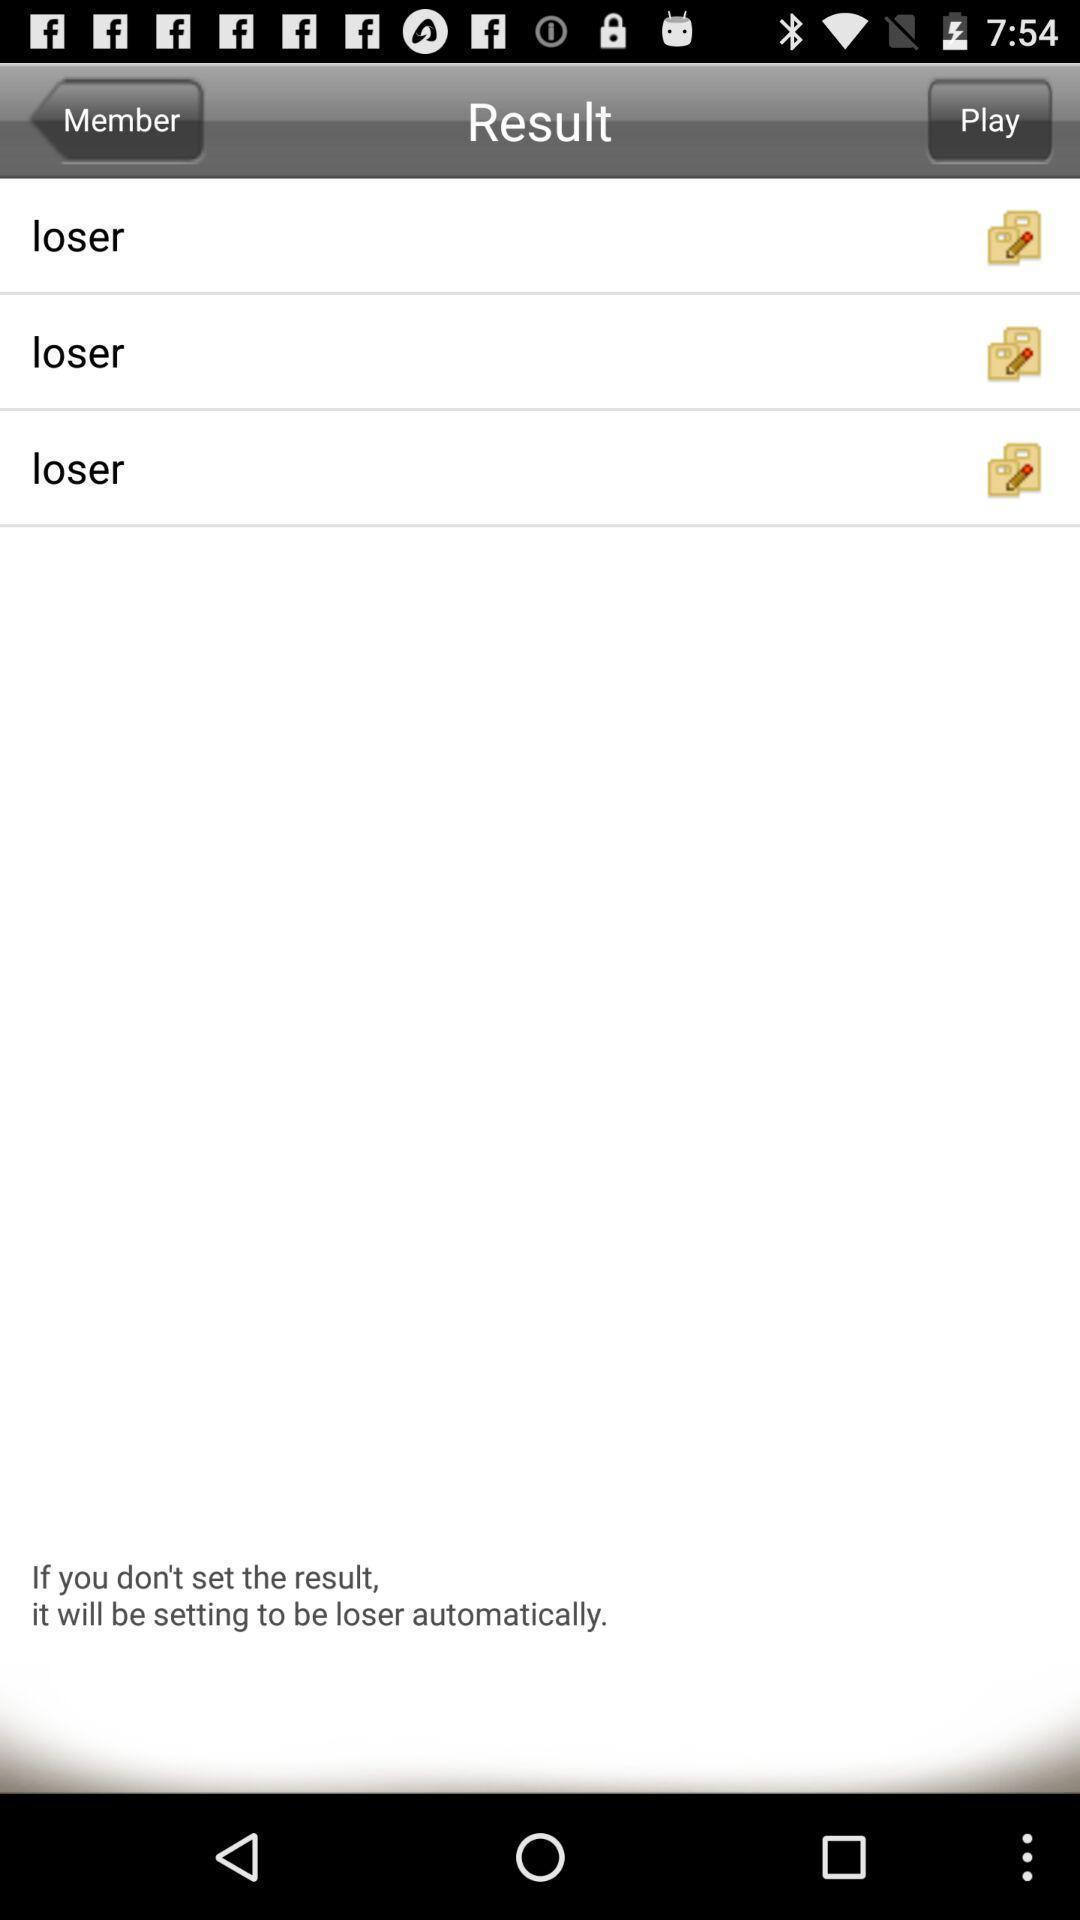Summarize the information in this screenshot. Screen displaying result page. 